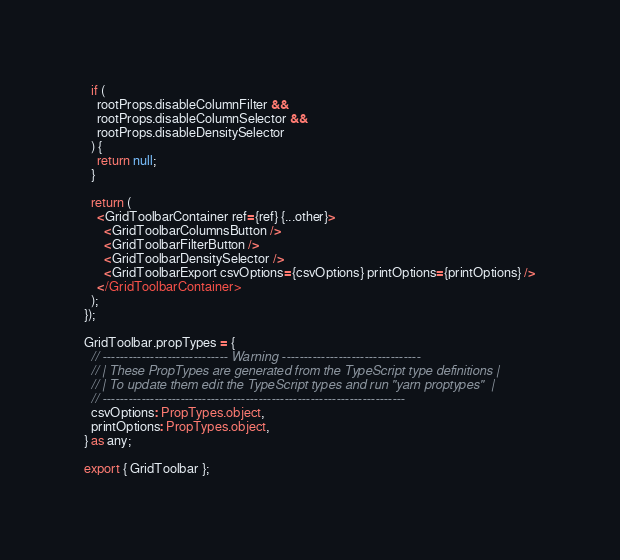<code> <loc_0><loc_0><loc_500><loc_500><_TypeScript_>  if (
    rootProps.disableColumnFilter &&
    rootProps.disableColumnSelector &&
    rootProps.disableDensitySelector
  ) {
    return null;
  }

  return (
    <GridToolbarContainer ref={ref} {...other}>
      <GridToolbarColumnsButton />
      <GridToolbarFilterButton />
      <GridToolbarDensitySelector />
      <GridToolbarExport csvOptions={csvOptions} printOptions={printOptions} />
    </GridToolbarContainer>
  );
});

GridToolbar.propTypes = {
  // ----------------------------- Warning --------------------------------
  // | These PropTypes are generated from the TypeScript type definitions |
  // | To update them edit the TypeScript types and run "yarn proptypes"  |
  // ----------------------------------------------------------------------
  csvOptions: PropTypes.object,
  printOptions: PropTypes.object,
} as any;

export { GridToolbar };
</code> 